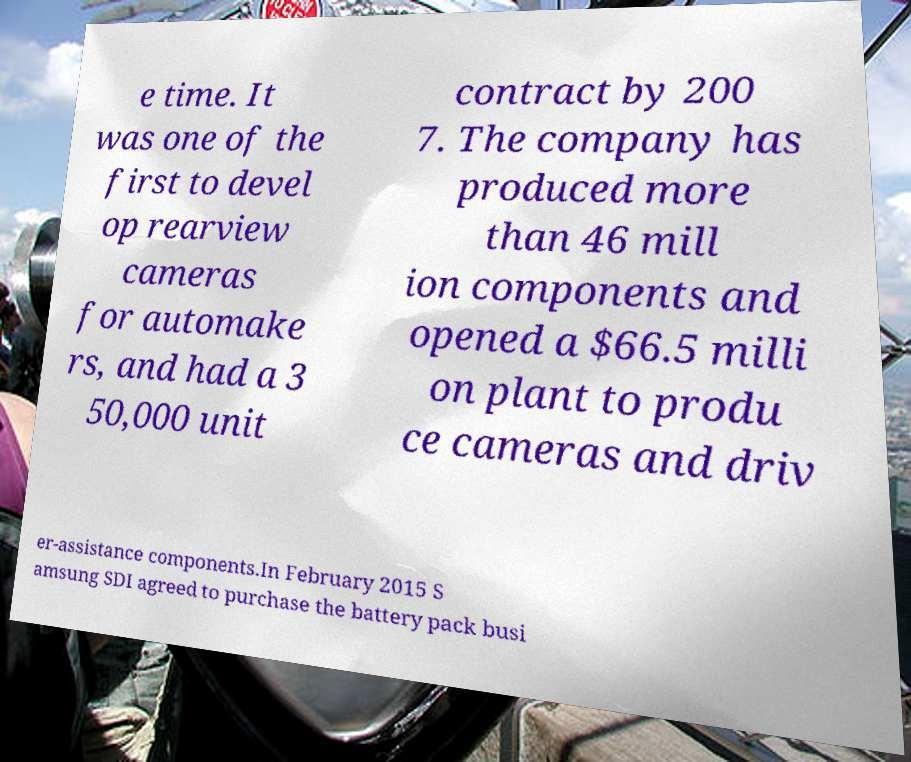Could you extract and type out the text from this image? e time. It was one of the first to devel op rearview cameras for automake rs, and had a 3 50,000 unit contract by 200 7. The company has produced more than 46 mill ion components and opened a $66.5 milli on plant to produ ce cameras and driv er-assistance components.In February 2015 S amsung SDI agreed to purchase the battery pack busi 